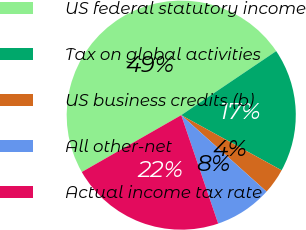Convert chart. <chart><loc_0><loc_0><loc_500><loc_500><pie_chart><fcel>US federal statutory income<fcel>Tax on global activities<fcel>US business credits (b)<fcel>All other-net<fcel>Actual income tax rate<nl><fcel>48.83%<fcel>17.44%<fcel>3.63%<fcel>8.15%<fcel>21.96%<nl></chart> 